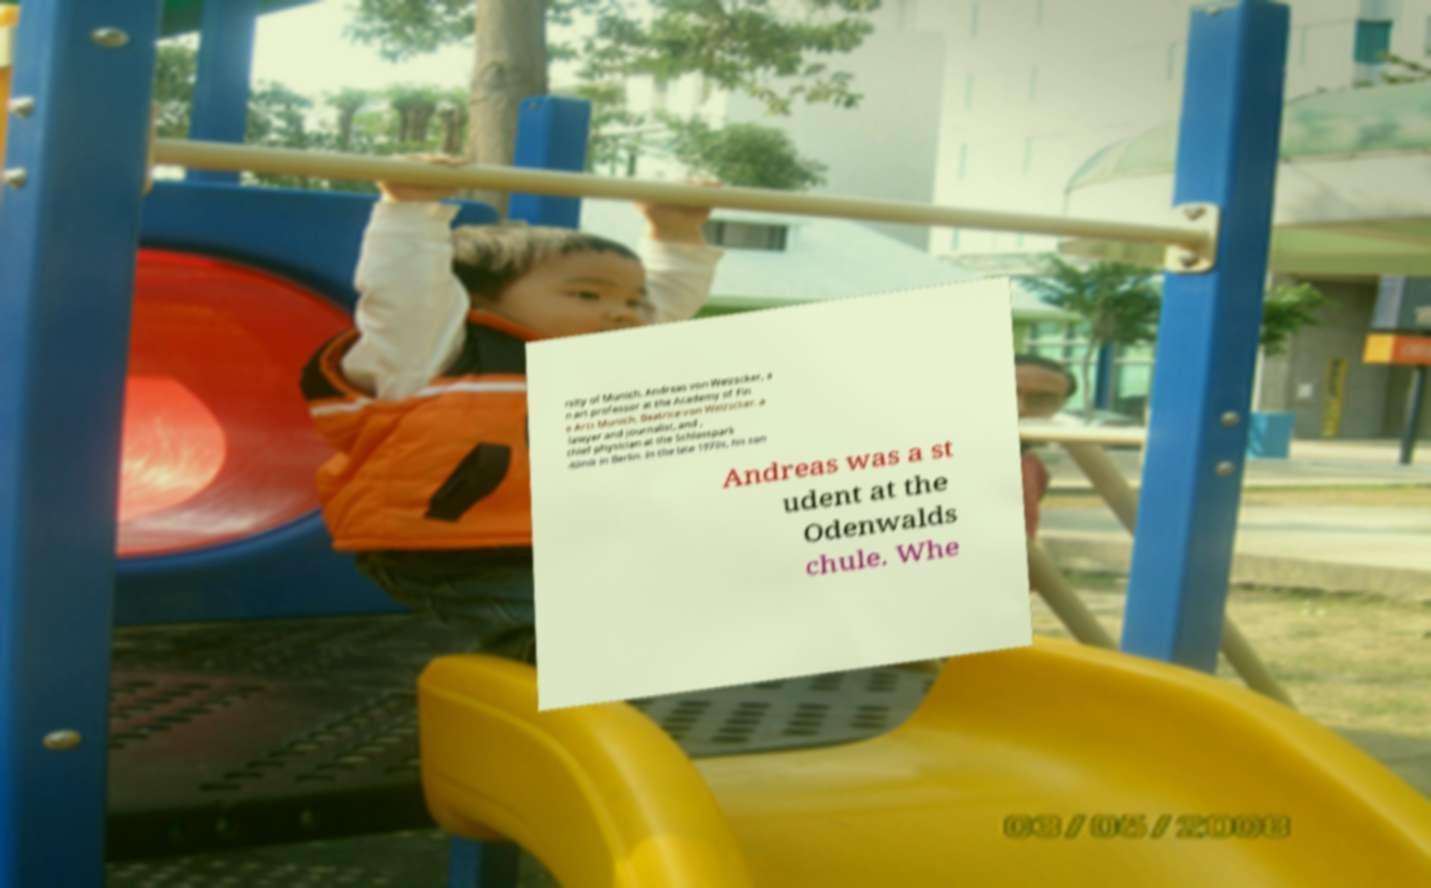Could you extract and type out the text from this image? rsity of Munich, Andreas von Weizscker, a n art professor at the Academy of Fin e Arts Munich, Beatrice von Weizscker, a lawyer and journalist, and , chief physician at the Schlosspark -Klinik in Berlin. In the late 1970s, his son Andreas was a st udent at the Odenwalds chule. Whe 